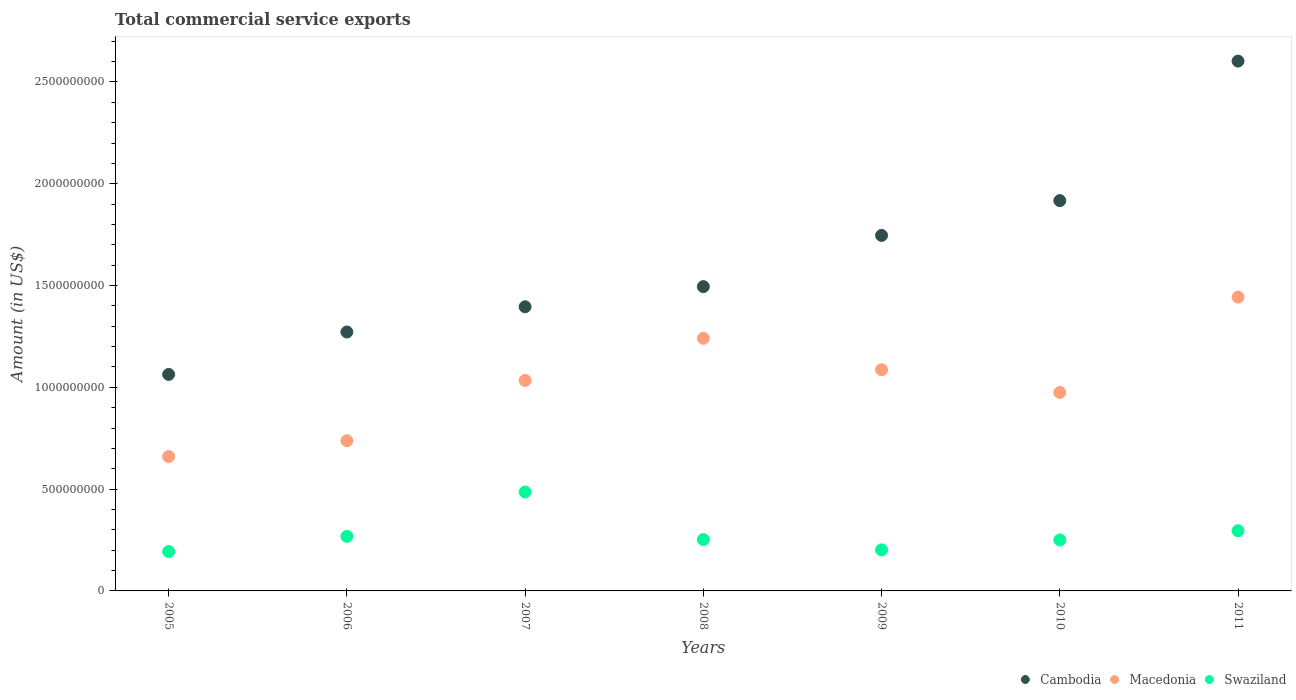Is the number of dotlines equal to the number of legend labels?
Ensure brevity in your answer.  Yes. What is the total commercial service exports in Swaziland in 2008?
Make the answer very short. 2.52e+08. Across all years, what is the maximum total commercial service exports in Cambodia?
Your answer should be very brief. 2.60e+09. Across all years, what is the minimum total commercial service exports in Cambodia?
Provide a short and direct response. 1.06e+09. In which year was the total commercial service exports in Cambodia maximum?
Make the answer very short. 2011. In which year was the total commercial service exports in Macedonia minimum?
Ensure brevity in your answer.  2005. What is the total total commercial service exports in Macedonia in the graph?
Offer a terse response. 7.18e+09. What is the difference between the total commercial service exports in Macedonia in 2006 and that in 2010?
Offer a terse response. -2.37e+08. What is the difference between the total commercial service exports in Cambodia in 2011 and the total commercial service exports in Swaziland in 2005?
Make the answer very short. 2.41e+09. What is the average total commercial service exports in Swaziland per year?
Offer a very short reply. 2.78e+08. In the year 2005, what is the difference between the total commercial service exports in Swaziland and total commercial service exports in Cambodia?
Offer a terse response. -8.70e+08. What is the ratio of the total commercial service exports in Cambodia in 2006 to that in 2011?
Offer a very short reply. 0.49. What is the difference between the highest and the second highest total commercial service exports in Cambodia?
Make the answer very short. 6.85e+08. What is the difference between the highest and the lowest total commercial service exports in Swaziland?
Offer a very short reply. 2.93e+08. In how many years, is the total commercial service exports in Cambodia greater than the average total commercial service exports in Cambodia taken over all years?
Provide a short and direct response. 3. Does the total commercial service exports in Cambodia monotonically increase over the years?
Give a very brief answer. Yes. Is the total commercial service exports in Swaziland strictly less than the total commercial service exports in Cambodia over the years?
Provide a succinct answer. Yes. Are the values on the major ticks of Y-axis written in scientific E-notation?
Provide a succinct answer. No. Does the graph contain any zero values?
Provide a short and direct response. No. Where does the legend appear in the graph?
Provide a short and direct response. Bottom right. How many legend labels are there?
Your response must be concise. 3. What is the title of the graph?
Make the answer very short. Total commercial service exports. What is the label or title of the X-axis?
Offer a terse response. Years. What is the Amount (in US$) of Cambodia in 2005?
Your answer should be very brief. 1.06e+09. What is the Amount (in US$) of Macedonia in 2005?
Your response must be concise. 6.60e+08. What is the Amount (in US$) in Swaziland in 2005?
Give a very brief answer. 1.93e+08. What is the Amount (in US$) in Cambodia in 2006?
Your answer should be very brief. 1.27e+09. What is the Amount (in US$) in Macedonia in 2006?
Provide a succinct answer. 7.38e+08. What is the Amount (in US$) of Swaziland in 2006?
Offer a terse response. 2.68e+08. What is the Amount (in US$) in Cambodia in 2007?
Offer a very short reply. 1.40e+09. What is the Amount (in US$) of Macedonia in 2007?
Your response must be concise. 1.03e+09. What is the Amount (in US$) of Swaziland in 2007?
Your answer should be compact. 4.86e+08. What is the Amount (in US$) of Cambodia in 2008?
Your answer should be compact. 1.49e+09. What is the Amount (in US$) in Macedonia in 2008?
Your answer should be compact. 1.24e+09. What is the Amount (in US$) in Swaziland in 2008?
Keep it short and to the point. 2.52e+08. What is the Amount (in US$) of Cambodia in 2009?
Your answer should be compact. 1.75e+09. What is the Amount (in US$) of Macedonia in 2009?
Your answer should be very brief. 1.09e+09. What is the Amount (in US$) in Swaziland in 2009?
Offer a very short reply. 2.02e+08. What is the Amount (in US$) of Cambodia in 2010?
Ensure brevity in your answer.  1.92e+09. What is the Amount (in US$) in Macedonia in 2010?
Ensure brevity in your answer.  9.75e+08. What is the Amount (in US$) in Swaziland in 2010?
Keep it short and to the point. 2.50e+08. What is the Amount (in US$) of Cambodia in 2011?
Give a very brief answer. 2.60e+09. What is the Amount (in US$) in Macedonia in 2011?
Give a very brief answer. 1.44e+09. What is the Amount (in US$) in Swaziland in 2011?
Your answer should be compact. 2.96e+08. Across all years, what is the maximum Amount (in US$) of Cambodia?
Provide a short and direct response. 2.60e+09. Across all years, what is the maximum Amount (in US$) in Macedonia?
Your answer should be compact. 1.44e+09. Across all years, what is the maximum Amount (in US$) in Swaziland?
Make the answer very short. 4.86e+08. Across all years, what is the minimum Amount (in US$) of Cambodia?
Give a very brief answer. 1.06e+09. Across all years, what is the minimum Amount (in US$) of Macedonia?
Provide a short and direct response. 6.60e+08. Across all years, what is the minimum Amount (in US$) of Swaziland?
Ensure brevity in your answer.  1.93e+08. What is the total Amount (in US$) in Cambodia in the graph?
Ensure brevity in your answer.  1.15e+1. What is the total Amount (in US$) of Macedonia in the graph?
Your response must be concise. 7.18e+09. What is the total Amount (in US$) of Swaziland in the graph?
Give a very brief answer. 1.95e+09. What is the difference between the Amount (in US$) of Cambodia in 2005 and that in 2006?
Keep it short and to the point. -2.08e+08. What is the difference between the Amount (in US$) of Macedonia in 2005 and that in 2006?
Your response must be concise. -7.75e+07. What is the difference between the Amount (in US$) of Swaziland in 2005 and that in 2006?
Your response must be concise. -7.48e+07. What is the difference between the Amount (in US$) of Cambodia in 2005 and that in 2007?
Your answer should be very brief. -3.32e+08. What is the difference between the Amount (in US$) in Macedonia in 2005 and that in 2007?
Provide a succinct answer. -3.74e+08. What is the difference between the Amount (in US$) in Swaziland in 2005 and that in 2007?
Give a very brief answer. -2.93e+08. What is the difference between the Amount (in US$) in Cambodia in 2005 and that in 2008?
Offer a terse response. -4.31e+08. What is the difference between the Amount (in US$) in Macedonia in 2005 and that in 2008?
Ensure brevity in your answer.  -5.81e+08. What is the difference between the Amount (in US$) of Swaziland in 2005 and that in 2008?
Give a very brief answer. -5.90e+07. What is the difference between the Amount (in US$) of Cambodia in 2005 and that in 2009?
Your answer should be compact. -6.83e+08. What is the difference between the Amount (in US$) of Macedonia in 2005 and that in 2009?
Offer a very short reply. -4.26e+08. What is the difference between the Amount (in US$) of Swaziland in 2005 and that in 2009?
Give a very brief answer. -8.29e+06. What is the difference between the Amount (in US$) in Cambodia in 2005 and that in 2010?
Your answer should be very brief. -8.54e+08. What is the difference between the Amount (in US$) of Macedonia in 2005 and that in 2010?
Your answer should be compact. -3.14e+08. What is the difference between the Amount (in US$) of Swaziland in 2005 and that in 2010?
Your answer should be very brief. -5.71e+07. What is the difference between the Amount (in US$) in Cambodia in 2005 and that in 2011?
Offer a terse response. -1.54e+09. What is the difference between the Amount (in US$) of Macedonia in 2005 and that in 2011?
Your answer should be compact. -7.83e+08. What is the difference between the Amount (in US$) of Swaziland in 2005 and that in 2011?
Make the answer very short. -1.02e+08. What is the difference between the Amount (in US$) of Cambodia in 2006 and that in 2007?
Your answer should be compact. -1.24e+08. What is the difference between the Amount (in US$) in Macedonia in 2006 and that in 2007?
Provide a succinct answer. -2.96e+08. What is the difference between the Amount (in US$) in Swaziland in 2006 and that in 2007?
Make the answer very short. -2.18e+08. What is the difference between the Amount (in US$) in Cambodia in 2006 and that in 2008?
Make the answer very short. -2.23e+08. What is the difference between the Amount (in US$) of Macedonia in 2006 and that in 2008?
Provide a succinct answer. -5.03e+08. What is the difference between the Amount (in US$) in Swaziland in 2006 and that in 2008?
Provide a short and direct response. 1.58e+07. What is the difference between the Amount (in US$) in Cambodia in 2006 and that in 2009?
Offer a terse response. -4.75e+08. What is the difference between the Amount (in US$) of Macedonia in 2006 and that in 2009?
Make the answer very short. -3.48e+08. What is the difference between the Amount (in US$) of Swaziland in 2006 and that in 2009?
Ensure brevity in your answer.  6.65e+07. What is the difference between the Amount (in US$) in Cambodia in 2006 and that in 2010?
Make the answer very short. -6.45e+08. What is the difference between the Amount (in US$) in Macedonia in 2006 and that in 2010?
Your answer should be compact. -2.37e+08. What is the difference between the Amount (in US$) in Swaziland in 2006 and that in 2010?
Give a very brief answer. 1.77e+07. What is the difference between the Amount (in US$) of Cambodia in 2006 and that in 2011?
Your response must be concise. -1.33e+09. What is the difference between the Amount (in US$) of Macedonia in 2006 and that in 2011?
Your answer should be very brief. -7.05e+08. What is the difference between the Amount (in US$) of Swaziland in 2006 and that in 2011?
Provide a succinct answer. -2.77e+07. What is the difference between the Amount (in US$) of Cambodia in 2007 and that in 2008?
Your response must be concise. -9.91e+07. What is the difference between the Amount (in US$) of Macedonia in 2007 and that in 2008?
Ensure brevity in your answer.  -2.07e+08. What is the difference between the Amount (in US$) in Swaziland in 2007 and that in 2008?
Your answer should be very brief. 2.34e+08. What is the difference between the Amount (in US$) of Cambodia in 2007 and that in 2009?
Give a very brief answer. -3.51e+08. What is the difference between the Amount (in US$) of Macedonia in 2007 and that in 2009?
Your answer should be very brief. -5.23e+07. What is the difference between the Amount (in US$) of Swaziland in 2007 and that in 2009?
Provide a succinct answer. 2.84e+08. What is the difference between the Amount (in US$) in Cambodia in 2007 and that in 2010?
Offer a very short reply. -5.21e+08. What is the difference between the Amount (in US$) of Macedonia in 2007 and that in 2010?
Ensure brevity in your answer.  5.94e+07. What is the difference between the Amount (in US$) in Swaziland in 2007 and that in 2010?
Your answer should be compact. 2.36e+08. What is the difference between the Amount (in US$) in Cambodia in 2007 and that in 2011?
Offer a very short reply. -1.21e+09. What is the difference between the Amount (in US$) in Macedonia in 2007 and that in 2011?
Offer a terse response. -4.09e+08. What is the difference between the Amount (in US$) in Swaziland in 2007 and that in 2011?
Make the answer very short. 1.90e+08. What is the difference between the Amount (in US$) of Cambodia in 2008 and that in 2009?
Keep it short and to the point. -2.52e+08. What is the difference between the Amount (in US$) of Macedonia in 2008 and that in 2009?
Your response must be concise. 1.55e+08. What is the difference between the Amount (in US$) in Swaziland in 2008 and that in 2009?
Your response must be concise. 5.07e+07. What is the difference between the Amount (in US$) in Cambodia in 2008 and that in 2010?
Offer a terse response. -4.22e+08. What is the difference between the Amount (in US$) of Macedonia in 2008 and that in 2010?
Offer a very short reply. 2.66e+08. What is the difference between the Amount (in US$) in Swaziland in 2008 and that in 2010?
Give a very brief answer. 1.93e+06. What is the difference between the Amount (in US$) in Cambodia in 2008 and that in 2011?
Give a very brief answer. -1.11e+09. What is the difference between the Amount (in US$) of Macedonia in 2008 and that in 2011?
Make the answer very short. -2.02e+08. What is the difference between the Amount (in US$) of Swaziland in 2008 and that in 2011?
Ensure brevity in your answer.  -4.35e+07. What is the difference between the Amount (in US$) in Cambodia in 2009 and that in 2010?
Your response must be concise. -1.71e+08. What is the difference between the Amount (in US$) in Macedonia in 2009 and that in 2010?
Give a very brief answer. 1.12e+08. What is the difference between the Amount (in US$) in Swaziland in 2009 and that in 2010?
Give a very brief answer. -4.88e+07. What is the difference between the Amount (in US$) in Cambodia in 2009 and that in 2011?
Provide a succinct answer. -8.56e+08. What is the difference between the Amount (in US$) of Macedonia in 2009 and that in 2011?
Offer a very short reply. -3.57e+08. What is the difference between the Amount (in US$) of Swaziland in 2009 and that in 2011?
Give a very brief answer. -9.42e+07. What is the difference between the Amount (in US$) of Cambodia in 2010 and that in 2011?
Your response must be concise. -6.85e+08. What is the difference between the Amount (in US$) in Macedonia in 2010 and that in 2011?
Give a very brief answer. -4.69e+08. What is the difference between the Amount (in US$) in Swaziland in 2010 and that in 2011?
Keep it short and to the point. -4.54e+07. What is the difference between the Amount (in US$) in Cambodia in 2005 and the Amount (in US$) in Macedonia in 2006?
Offer a terse response. 3.26e+08. What is the difference between the Amount (in US$) in Cambodia in 2005 and the Amount (in US$) in Swaziland in 2006?
Provide a short and direct response. 7.95e+08. What is the difference between the Amount (in US$) in Macedonia in 2005 and the Amount (in US$) in Swaziland in 2006?
Your response must be concise. 3.92e+08. What is the difference between the Amount (in US$) of Cambodia in 2005 and the Amount (in US$) of Macedonia in 2007?
Provide a succinct answer. 2.94e+07. What is the difference between the Amount (in US$) in Cambodia in 2005 and the Amount (in US$) in Swaziland in 2007?
Ensure brevity in your answer.  5.78e+08. What is the difference between the Amount (in US$) in Macedonia in 2005 and the Amount (in US$) in Swaziland in 2007?
Your answer should be very brief. 1.75e+08. What is the difference between the Amount (in US$) in Cambodia in 2005 and the Amount (in US$) in Macedonia in 2008?
Your response must be concise. -1.77e+08. What is the difference between the Amount (in US$) of Cambodia in 2005 and the Amount (in US$) of Swaziland in 2008?
Offer a terse response. 8.11e+08. What is the difference between the Amount (in US$) of Macedonia in 2005 and the Amount (in US$) of Swaziland in 2008?
Your response must be concise. 4.08e+08. What is the difference between the Amount (in US$) in Cambodia in 2005 and the Amount (in US$) in Macedonia in 2009?
Make the answer very short. -2.29e+07. What is the difference between the Amount (in US$) in Cambodia in 2005 and the Amount (in US$) in Swaziland in 2009?
Your response must be concise. 8.62e+08. What is the difference between the Amount (in US$) of Macedonia in 2005 and the Amount (in US$) of Swaziland in 2009?
Provide a succinct answer. 4.59e+08. What is the difference between the Amount (in US$) in Cambodia in 2005 and the Amount (in US$) in Macedonia in 2010?
Give a very brief answer. 8.88e+07. What is the difference between the Amount (in US$) of Cambodia in 2005 and the Amount (in US$) of Swaziland in 2010?
Provide a short and direct response. 8.13e+08. What is the difference between the Amount (in US$) of Macedonia in 2005 and the Amount (in US$) of Swaziland in 2010?
Offer a terse response. 4.10e+08. What is the difference between the Amount (in US$) of Cambodia in 2005 and the Amount (in US$) of Macedonia in 2011?
Your response must be concise. -3.80e+08. What is the difference between the Amount (in US$) in Cambodia in 2005 and the Amount (in US$) in Swaziland in 2011?
Your response must be concise. 7.68e+08. What is the difference between the Amount (in US$) in Macedonia in 2005 and the Amount (in US$) in Swaziland in 2011?
Keep it short and to the point. 3.65e+08. What is the difference between the Amount (in US$) of Cambodia in 2006 and the Amount (in US$) of Macedonia in 2007?
Keep it short and to the point. 2.38e+08. What is the difference between the Amount (in US$) in Cambodia in 2006 and the Amount (in US$) in Swaziland in 2007?
Offer a terse response. 7.86e+08. What is the difference between the Amount (in US$) of Macedonia in 2006 and the Amount (in US$) of Swaziland in 2007?
Make the answer very short. 2.52e+08. What is the difference between the Amount (in US$) in Cambodia in 2006 and the Amount (in US$) in Macedonia in 2008?
Offer a very short reply. 3.10e+07. What is the difference between the Amount (in US$) in Cambodia in 2006 and the Amount (in US$) in Swaziland in 2008?
Keep it short and to the point. 1.02e+09. What is the difference between the Amount (in US$) in Macedonia in 2006 and the Amount (in US$) in Swaziland in 2008?
Make the answer very short. 4.86e+08. What is the difference between the Amount (in US$) of Cambodia in 2006 and the Amount (in US$) of Macedonia in 2009?
Offer a very short reply. 1.86e+08. What is the difference between the Amount (in US$) in Cambodia in 2006 and the Amount (in US$) in Swaziland in 2009?
Provide a short and direct response. 1.07e+09. What is the difference between the Amount (in US$) in Macedonia in 2006 and the Amount (in US$) in Swaziland in 2009?
Ensure brevity in your answer.  5.36e+08. What is the difference between the Amount (in US$) of Cambodia in 2006 and the Amount (in US$) of Macedonia in 2010?
Keep it short and to the point. 2.97e+08. What is the difference between the Amount (in US$) of Cambodia in 2006 and the Amount (in US$) of Swaziland in 2010?
Make the answer very short. 1.02e+09. What is the difference between the Amount (in US$) in Macedonia in 2006 and the Amount (in US$) in Swaziland in 2010?
Offer a terse response. 4.88e+08. What is the difference between the Amount (in US$) in Cambodia in 2006 and the Amount (in US$) in Macedonia in 2011?
Provide a succinct answer. -1.71e+08. What is the difference between the Amount (in US$) of Cambodia in 2006 and the Amount (in US$) of Swaziland in 2011?
Ensure brevity in your answer.  9.76e+08. What is the difference between the Amount (in US$) in Macedonia in 2006 and the Amount (in US$) in Swaziland in 2011?
Keep it short and to the point. 4.42e+08. What is the difference between the Amount (in US$) in Cambodia in 2007 and the Amount (in US$) in Macedonia in 2008?
Keep it short and to the point. 1.55e+08. What is the difference between the Amount (in US$) of Cambodia in 2007 and the Amount (in US$) of Swaziland in 2008?
Offer a terse response. 1.14e+09. What is the difference between the Amount (in US$) of Macedonia in 2007 and the Amount (in US$) of Swaziland in 2008?
Offer a terse response. 7.82e+08. What is the difference between the Amount (in US$) of Cambodia in 2007 and the Amount (in US$) of Macedonia in 2009?
Provide a succinct answer. 3.09e+08. What is the difference between the Amount (in US$) in Cambodia in 2007 and the Amount (in US$) in Swaziland in 2009?
Your response must be concise. 1.19e+09. What is the difference between the Amount (in US$) in Macedonia in 2007 and the Amount (in US$) in Swaziland in 2009?
Offer a terse response. 8.33e+08. What is the difference between the Amount (in US$) in Cambodia in 2007 and the Amount (in US$) in Macedonia in 2010?
Your answer should be compact. 4.21e+08. What is the difference between the Amount (in US$) in Cambodia in 2007 and the Amount (in US$) in Swaziland in 2010?
Keep it short and to the point. 1.15e+09. What is the difference between the Amount (in US$) in Macedonia in 2007 and the Amount (in US$) in Swaziland in 2010?
Give a very brief answer. 7.84e+08. What is the difference between the Amount (in US$) of Cambodia in 2007 and the Amount (in US$) of Macedonia in 2011?
Your response must be concise. -4.75e+07. What is the difference between the Amount (in US$) of Cambodia in 2007 and the Amount (in US$) of Swaziland in 2011?
Give a very brief answer. 1.10e+09. What is the difference between the Amount (in US$) in Macedonia in 2007 and the Amount (in US$) in Swaziland in 2011?
Your answer should be very brief. 7.38e+08. What is the difference between the Amount (in US$) of Cambodia in 2008 and the Amount (in US$) of Macedonia in 2009?
Your response must be concise. 4.08e+08. What is the difference between the Amount (in US$) of Cambodia in 2008 and the Amount (in US$) of Swaziland in 2009?
Make the answer very short. 1.29e+09. What is the difference between the Amount (in US$) in Macedonia in 2008 and the Amount (in US$) in Swaziland in 2009?
Provide a succinct answer. 1.04e+09. What is the difference between the Amount (in US$) in Cambodia in 2008 and the Amount (in US$) in Macedonia in 2010?
Your response must be concise. 5.20e+08. What is the difference between the Amount (in US$) in Cambodia in 2008 and the Amount (in US$) in Swaziland in 2010?
Provide a short and direct response. 1.24e+09. What is the difference between the Amount (in US$) in Macedonia in 2008 and the Amount (in US$) in Swaziland in 2010?
Offer a very short reply. 9.91e+08. What is the difference between the Amount (in US$) in Cambodia in 2008 and the Amount (in US$) in Macedonia in 2011?
Your response must be concise. 5.16e+07. What is the difference between the Amount (in US$) of Cambodia in 2008 and the Amount (in US$) of Swaziland in 2011?
Make the answer very short. 1.20e+09. What is the difference between the Amount (in US$) of Macedonia in 2008 and the Amount (in US$) of Swaziland in 2011?
Ensure brevity in your answer.  9.45e+08. What is the difference between the Amount (in US$) in Cambodia in 2009 and the Amount (in US$) in Macedonia in 2010?
Offer a very short reply. 7.72e+08. What is the difference between the Amount (in US$) in Cambodia in 2009 and the Amount (in US$) in Swaziland in 2010?
Your answer should be very brief. 1.50e+09. What is the difference between the Amount (in US$) in Macedonia in 2009 and the Amount (in US$) in Swaziland in 2010?
Offer a very short reply. 8.36e+08. What is the difference between the Amount (in US$) of Cambodia in 2009 and the Amount (in US$) of Macedonia in 2011?
Provide a short and direct response. 3.03e+08. What is the difference between the Amount (in US$) in Cambodia in 2009 and the Amount (in US$) in Swaziland in 2011?
Provide a succinct answer. 1.45e+09. What is the difference between the Amount (in US$) of Macedonia in 2009 and the Amount (in US$) of Swaziland in 2011?
Your response must be concise. 7.91e+08. What is the difference between the Amount (in US$) of Cambodia in 2010 and the Amount (in US$) of Macedonia in 2011?
Your response must be concise. 4.74e+08. What is the difference between the Amount (in US$) of Cambodia in 2010 and the Amount (in US$) of Swaziland in 2011?
Offer a very short reply. 1.62e+09. What is the difference between the Amount (in US$) of Macedonia in 2010 and the Amount (in US$) of Swaziland in 2011?
Provide a short and direct response. 6.79e+08. What is the average Amount (in US$) in Cambodia per year?
Ensure brevity in your answer.  1.64e+09. What is the average Amount (in US$) in Macedonia per year?
Provide a short and direct response. 1.03e+09. What is the average Amount (in US$) in Swaziland per year?
Provide a succinct answer. 2.78e+08. In the year 2005, what is the difference between the Amount (in US$) of Cambodia and Amount (in US$) of Macedonia?
Give a very brief answer. 4.03e+08. In the year 2005, what is the difference between the Amount (in US$) in Cambodia and Amount (in US$) in Swaziland?
Provide a succinct answer. 8.70e+08. In the year 2005, what is the difference between the Amount (in US$) of Macedonia and Amount (in US$) of Swaziland?
Offer a very short reply. 4.67e+08. In the year 2006, what is the difference between the Amount (in US$) of Cambodia and Amount (in US$) of Macedonia?
Ensure brevity in your answer.  5.34e+08. In the year 2006, what is the difference between the Amount (in US$) in Cambodia and Amount (in US$) in Swaziland?
Your response must be concise. 1.00e+09. In the year 2006, what is the difference between the Amount (in US$) of Macedonia and Amount (in US$) of Swaziland?
Your answer should be very brief. 4.70e+08. In the year 2007, what is the difference between the Amount (in US$) in Cambodia and Amount (in US$) in Macedonia?
Give a very brief answer. 3.62e+08. In the year 2007, what is the difference between the Amount (in US$) of Cambodia and Amount (in US$) of Swaziland?
Ensure brevity in your answer.  9.10e+08. In the year 2007, what is the difference between the Amount (in US$) of Macedonia and Amount (in US$) of Swaziland?
Keep it short and to the point. 5.48e+08. In the year 2008, what is the difference between the Amount (in US$) in Cambodia and Amount (in US$) in Macedonia?
Keep it short and to the point. 2.54e+08. In the year 2008, what is the difference between the Amount (in US$) in Cambodia and Amount (in US$) in Swaziland?
Your answer should be compact. 1.24e+09. In the year 2008, what is the difference between the Amount (in US$) of Macedonia and Amount (in US$) of Swaziland?
Offer a very short reply. 9.89e+08. In the year 2009, what is the difference between the Amount (in US$) of Cambodia and Amount (in US$) of Macedonia?
Your answer should be very brief. 6.60e+08. In the year 2009, what is the difference between the Amount (in US$) in Cambodia and Amount (in US$) in Swaziland?
Your answer should be compact. 1.54e+09. In the year 2009, what is the difference between the Amount (in US$) in Macedonia and Amount (in US$) in Swaziland?
Provide a succinct answer. 8.85e+08. In the year 2010, what is the difference between the Amount (in US$) of Cambodia and Amount (in US$) of Macedonia?
Provide a short and direct response. 9.43e+08. In the year 2010, what is the difference between the Amount (in US$) in Cambodia and Amount (in US$) in Swaziland?
Offer a terse response. 1.67e+09. In the year 2010, what is the difference between the Amount (in US$) of Macedonia and Amount (in US$) of Swaziland?
Ensure brevity in your answer.  7.24e+08. In the year 2011, what is the difference between the Amount (in US$) of Cambodia and Amount (in US$) of Macedonia?
Make the answer very short. 1.16e+09. In the year 2011, what is the difference between the Amount (in US$) of Cambodia and Amount (in US$) of Swaziland?
Your answer should be compact. 2.31e+09. In the year 2011, what is the difference between the Amount (in US$) in Macedonia and Amount (in US$) in Swaziland?
Keep it short and to the point. 1.15e+09. What is the ratio of the Amount (in US$) of Cambodia in 2005 to that in 2006?
Give a very brief answer. 0.84. What is the ratio of the Amount (in US$) in Macedonia in 2005 to that in 2006?
Give a very brief answer. 0.89. What is the ratio of the Amount (in US$) in Swaziland in 2005 to that in 2006?
Make the answer very short. 0.72. What is the ratio of the Amount (in US$) of Cambodia in 2005 to that in 2007?
Give a very brief answer. 0.76. What is the ratio of the Amount (in US$) of Macedonia in 2005 to that in 2007?
Make the answer very short. 0.64. What is the ratio of the Amount (in US$) of Swaziland in 2005 to that in 2007?
Your answer should be compact. 0.4. What is the ratio of the Amount (in US$) of Cambodia in 2005 to that in 2008?
Ensure brevity in your answer.  0.71. What is the ratio of the Amount (in US$) of Macedonia in 2005 to that in 2008?
Keep it short and to the point. 0.53. What is the ratio of the Amount (in US$) of Swaziland in 2005 to that in 2008?
Provide a short and direct response. 0.77. What is the ratio of the Amount (in US$) of Cambodia in 2005 to that in 2009?
Give a very brief answer. 0.61. What is the ratio of the Amount (in US$) of Macedonia in 2005 to that in 2009?
Provide a succinct answer. 0.61. What is the ratio of the Amount (in US$) in Swaziland in 2005 to that in 2009?
Provide a short and direct response. 0.96. What is the ratio of the Amount (in US$) of Cambodia in 2005 to that in 2010?
Keep it short and to the point. 0.55. What is the ratio of the Amount (in US$) in Macedonia in 2005 to that in 2010?
Offer a terse response. 0.68. What is the ratio of the Amount (in US$) in Swaziland in 2005 to that in 2010?
Your answer should be very brief. 0.77. What is the ratio of the Amount (in US$) of Cambodia in 2005 to that in 2011?
Your response must be concise. 0.41. What is the ratio of the Amount (in US$) of Macedonia in 2005 to that in 2011?
Provide a succinct answer. 0.46. What is the ratio of the Amount (in US$) of Swaziland in 2005 to that in 2011?
Your answer should be very brief. 0.65. What is the ratio of the Amount (in US$) in Cambodia in 2006 to that in 2007?
Offer a terse response. 0.91. What is the ratio of the Amount (in US$) in Macedonia in 2006 to that in 2007?
Your answer should be compact. 0.71. What is the ratio of the Amount (in US$) in Swaziland in 2006 to that in 2007?
Keep it short and to the point. 0.55. What is the ratio of the Amount (in US$) of Cambodia in 2006 to that in 2008?
Make the answer very short. 0.85. What is the ratio of the Amount (in US$) of Macedonia in 2006 to that in 2008?
Your answer should be compact. 0.59. What is the ratio of the Amount (in US$) in Swaziland in 2006 to that in 2008?
Give a very brief answer. 1.06. What is the ratio of the Amount (in US$) in Cambodia in 2006 to that in 2009?
Offer a terse response. 0.73. What is the ratio of the Amount (in US$) of Macedonia in 2006 to that in 2009?
Give a very brief answer. 0.68. What is the ratio of the Amount (in US$) in Swaziland in 2006 to that in 2009?
Keep it short and to the point. 1.33. What is the ratio of the Amount (in US$) in Cambodia in 2006 to that in 2010?
Your answer should be very brief. 0.66. What is the ratio of the Amount (in US$) of Macedonia in 2006 to that in 2010?
Offer a very short reply. 0.76. What is the ratio of the Amount (in US$) of Swaziland in 2006 to that in 2010?
Provide a succinct answer. 1.07. What is the ratio of the Amount (in US$) in Cambodia in 2006 to that in 2011?
Keep it short and to the point. 0.49. What is the ratio of the Amount (in US$) of Macedonia in 2006 to that in 2011?
Make the answer very short. 0.51. What is the ratio of the Amount (in US$) in Swaziland in 2006 to that in 2011?
Offer a very short reply. 0.91. What is the ratio of the Amount (in US$) in Cambodia in 2007 to that in 2008?
Make the answer very short. 0.93. What is the ratio of the Amount (in US$) in Macedonia in 2007 to that in 2008?
Your answer should be very brief. 0.83. What is the ratio of the Amount (in US$) of Swaziland in 2007 to that in 2008?
Provide a short and direct response. 1.93. What is the ratio of the Amount (in US$) in Cambodia in 2007 to that in 2009?
Keep it short and to the point. 0.8. What is the ratio of the Amount (in US$) in Macedonia in 2007 to that in 2009?
Offer a terse response. 0.95. What is the ratio of the Amount (in US$) in Swaziland in 2007 to that in 2009?
Your answer should be compact. 2.41. What is the ratio of the Amount (in US$) in Cambodia in 2007 to that in 2010?
Keep it short and to the point. 0.73. What is the ratio of the Amount (in US$) of Macedonia in 2007 to that in 2010?
Your response must be concise. 1.06. What is the ratio of the Amount (in US$) in Swaziland in 2007 to that in 2010?
Offer a very short reply. 1.94. What is the ratio of the Amount (in US$) of Cambodia in 2007 to that in 2011?
Offer a very short reply. 0.54. What is the ratio of the Amount (in US$) in Macedonia in 2007 to that in 2011?
Ensure brevity in your answer.  0.72. What is the ratio of the Amount (in US$) in Swaziland in 2007 to that in 2011?
Make the answer very short. 1.64. What is the ratio of the Amount (in US$) of Cambodia in 2008 to that in 2009?
Make the answer very short. 0.86. What is the ratio of the Amount (in US$) of Macedonia in 2008 to that in 2009?
Your answer should be compact. 1.14. What is the ratio of the Amount (in US$) of Swaziland in 2008 to that in 2009?
Your answer should be compact. 1.25. What is the ratio of the Amount (in US$) of Cambodia in 2008 to that in 2010?
Offer a terse response. 0.78. What is the ratio of the Amount (in US$) of Macedonia in 2008 to that in 2010?
Give a very brief answer. 1.27. What is the ratio of the Amount (in US$) in Swaziland in 2008 to that in 2010?
Provide a short and direct response. 1.01. What is the ratio of the Amount (in US$) in Cambodia in 2008 to that in 2011?
Make the answer very short. 0.57. What is the ratio of the Amount (in US$) of Macedonia in 2008 to that in 2011?
Your answer should be compact. 0.86. What is the ratio of the Amount (in US$) of Swaziland in 2008 to that in 2011?
Make the answer very short. 0.85. What is the ratio of the Amount (in US$) of Cambodia in 2009 to that in 2010?
Your response must be concise. 0.91. What is the ratio of the Amount (in US$) in Macedonia in 2009 to that in 2010?
Make the answer very short. 1.11. What is the ratio of the Amount (in US$) in Swaziland in 2009 to that in 2010?
Offer a very short reply. 0.81. What is the ratio of the Amount (in US$) in Cambodia in 2009 to that in 2011?
Offer a very short reply. 0.67. What is the ratio of the Amount (in US$) in Macedonia in 2009 to that in 2011?
Ensure brevity in your answer.  0.75. What is the ratio of the Amount (in US$) in Swaziland in 2009 to that in 2011?
Give a very brief answer. 0.68. What is the ratio of the Amount (in US$) of Cambodia in 2010 to that in 2011?
Give a very brief answer. 0.74. What is the ratio of the Amount (in US$) in Macedonia in 2010 to that in 2011?
Make the answer very short. 0.68. What is the ratio of the Amount (in US$) in Swaziland in 2010 to that in 2011?
Give a very brief answer. 0.85. What is the difference between the highest and the second highest Amount (in US$) of Cambodia?
Provide a short and direct response. 6.85e+08. What is the difference between the highest and the second highest Amount (in US$) of Macedonia?
Keep it short and to the point. 2.02e+08. What is the difference between the highest and the second highest Amount (in US$) in Swaziland?
Offer a very short reply. 1.90e+08. What is the difference between the highest and the lowest Amount (in US$) in Cambodia?
Offer a very short reply. 1.54e+09. What is the difference between the highest and the lowest Amount (in US$) in Macedonia?
Provide a succinct answer. 7.83e+08. What is the difference between the highest and the lowest Amount (in US$) of Swaziland?
Give a very brief answer. 2.93e+08. 